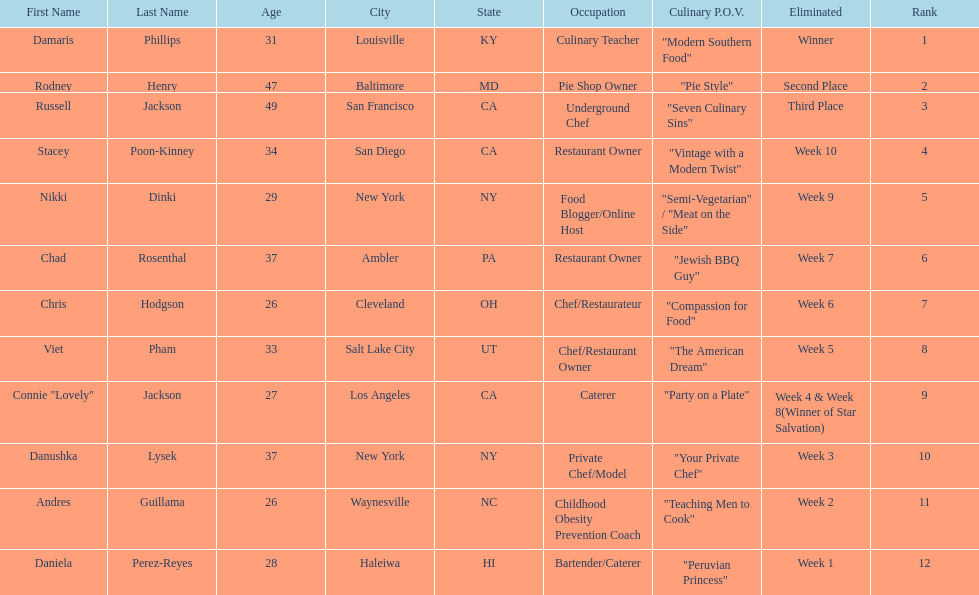Which competitor only lasted two weeks? Andres Guillama. 